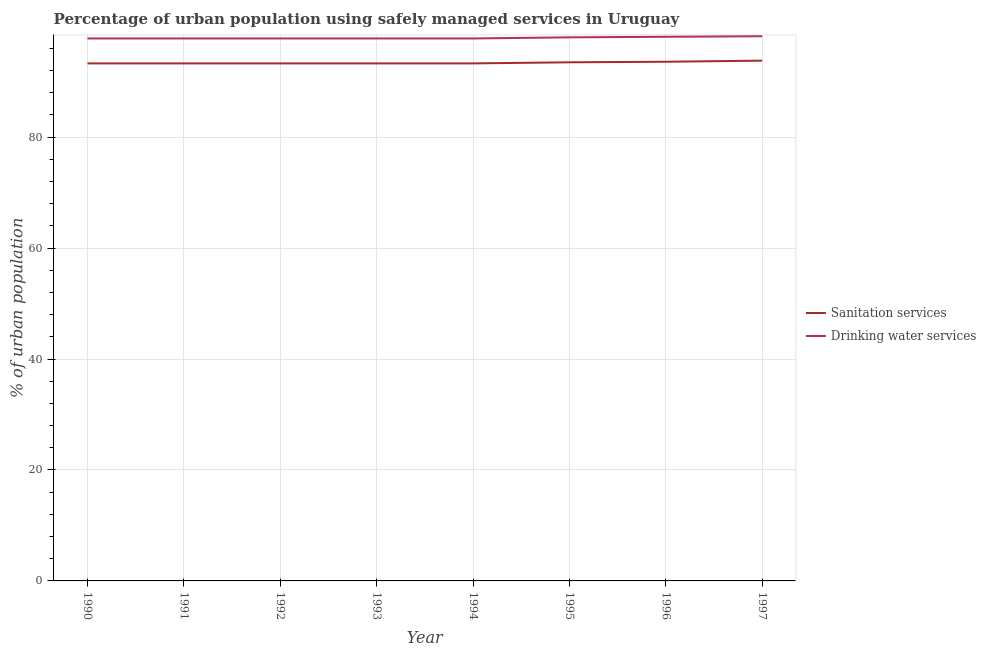How many different coloured lines are there?
Ensure brevity in your answer.  2. What is the percentage of urban population who used drinking water services in 1991?
Ensure brevity in your answer.  97.8. Across all years, what is the maximum percentage of urban population who used sanitation services?
Give a very brief answer. 93.8. Across all years, what is the minimum percentage of urban population who used sanitation services?
Offer a very short reply. 93.3. In which year was the percentage of urban population who used sanitation services maximum?
Make the answer very short. 1997. What is the total percentage of urban population who used sanitation services in the graph?
Provide a succinct answer. 747.4. What is the difference between the percentage of urban population who used sanitation services in 1991 and the percentage of urban population who used drinking water services in 1996?
Your answer should be very brief. -4.8. What is the average percentage of urban population who used sanitation services per year?
Ensure brevity in your answer.  93.42. In the year 1997, what is the difference between the percentage of urban population who used sanitation services and percentage of urban population who used drinking water services?
Your answer should be very brief. -4.4. In how many years, is the percentage of urban population who used drinking water services greater than 48 %?
Your response must be concise. 8. Is the percentage of urban population who used sanitation services in 1993 less than that in 1995?
Make the answer very short. Yes. What is the difference between the highest and the second highest percentage of urban population who used drinking water services?
Provide a short and direct response. 0.1. What is the difference between the highest and the lowest percentage of urban population who used drinking water services?
Offer a very short reply. 0.4. Is the sum of the percentage of urban population who used drinking water services in 1992 and 1993 greater than the maximum percentage of urban population who used sanitation services across all years?
Ensure brevity in your answer.  Yes. Does the percentage of urban population who used sanitation services monotonically increase over the years?
Give a very brief answer. No. How many lines are there?
Make the answer very short. 2. What is the difference between two consecutive major ticks on the Y-axis?
Keep it short and to the point. 20. Does the graph contain any zero values?
Keep it short and to the point. No. Does the graph contain grids?
Your answer should be compact. Yes. Where does the legend appear in the graph?
Offer a terse response. Center right. What is the title of the graph?
Make the answer very short. Percentage of urban population using safely managed services in Uruguay. Does "% of gross capital formation" appear as one of the legend labels in the graph?
Make the answer very short. No. What is the label or title of the Y-axis?
Offer a very short reply. % of urban population. What is the % of urban population of Sanitation services in 1990?
Give a very brief answer. 93.3. What is the % of urban population in Drinking water services in 1990?
Offer a very short reply. 97.8. What is the % of urban population of Sanitation services in 1991?
Offer a very short reply. 93.3. What is the % of urban population in Drinking water services in 1991?
Offer a very short reply. 97.8. What is the % of urban population of Sanitation services in 1992?
Make the answer very short. 93.3. What is the % of urban population of Drinking water services in 1992?
Provide a short and direct response. 97.8. What is the % of urban population of Sanitation services in 1993?
Your answer should be very brief. 93.3. What is the % of urban population in Drinking water services in 1993?
Your answer should be very brief. 97.8. What is the % of urban population in Sanitation services in 1994?
Provide a succinct answer. 93.3. What is the % of urban population of Drinking water services in 1994?
Offer a terse response. 97.8. What is the % of urban population in Sanitation services in 1995?
Offer a terse response. 93.5. What is the % of urban population of Sanitation services in 1996?
Give a very brief answer. 93.6. What is the % of urban population of Drinking water services in 1996?
Make the answer very short. 98.1. What is the % of urban population of Sanitation services in 1997?
Provide a succinct answer. 93.8. What is the % of urban population in Drinking water services in 1997?
Offer a terse response. 98.2. Across all years, what is the maximum % of urban population of Sanitation services?
Your answer should be very brief. 93.8. Across all years, what is the maximum % of urban population in Drinking water services?
Your answer should be compact. 98.2. Across all years, what is the minimum % of urban population in Sanitation services?
Offer a very short reply. 93.3. Across all years, what is the minimum % of urban population of Drinking water services?
Make the answer very short. 97.8. What is the total % of urban population of Sanitation services in the graph?
Provide a short and direct response. 747.4. What is the total % of urban population in Drinking water services in the graph?
Offer a very short reply. 783.3. What is the difference between the % of urban population of Sanitation services in 1990 and that in 1992?
Your answer should be compact. 0. What is the difference between the % of urban population of Drinking water services in 1990 and that in 1992?
Make the answer very short. 0. What is the difference between the % of urban population of Sanitation services in 1990 and that in 1993?
Offer a very short reply. 0. What is the difference between the % of urban population in Drinking water services in 1990 and that in 1993?
Provide a succinct answer. 0. What is the difference between the % of urban population in Sanitation services in 1990 and that in 1994?
Offer a very short reply. 0. What is the difference between the % of urban population in Sanitation services in 1990 and that in 1996?
Make the answer very short. -0.3. What is the difference between the % of urban population in Sanitation services in 1990 and that in 1997?
Your answer should be compact. -0.5. What is the difference between the % of urban population of Drinking water services in 1990 and that in 1997?
Your answer should be very brief. -0.4. What is the difference between the % of urban population in Drinking water services in 1991 and that in 1992?
Provide a succinct answer. 0. What is the difference between the % of urban population of Sanitation services in 1991 and that in 1993?
Provide a succinct answer. 0. What is the difference between the % of urban population of Sanitation services in 1991 and that in 1997?
Your answer should be compact. -0.5. What is the difference between the % of urban population of Drinking water services in 1991 and that in 1997?
Give a very brief answer. -0.4. What is the difference between the % of urban population of Drinking water services in 1992 and that in 1993?
Your answer should be very brief. 0. What is the difference between the % of urban population in Sanitation services in 1992 and that in 1994?
Offer a terse response. 0. What is the difference between the % of urban population of Sanitation services in 1992 and that in 1995?
Make the answer very short. -0.2. What is the difference between the % of urban population of Drinking water services in 1992 and that in 1997?
Give a very brief answer. -0.4. What is the difference between the % of urban population in Sanitation services in 1993 and that in 1995?
Make the answer very short. -0.2. What is the difference between the % of urban population in Drinking water services in 1993 and that in 1995?
Your response must be concise. -0.2. What is the difference between the % of urban population of Sanitation services in 1993 and that in 1996?
Provide a succinct answer. -0.3. What is the difference between the % of urban population in Drinking water services in 1993 and that in 1997?
Make the answer very short. -0.4. What is the difference between the % of urban population of Sanitation services in 1994 and that in 1995?
Ensure brevity in your answer.  -0.2. What is the difference between the % of urban population in Sanitation services in 1994 and that in 1996?
Provide a succinct answer. -0.3. What is the difference between the % of urban population of Sanitation services in 1995 and that in 1996?
Ensure brevity in your answer.  -0.1. What is the difference between the % of urban population of Sanitation services in 1995 and that in 1997?
Ensure brevity in your answer.  -0.3. What is the difference between the % of urban population in Drinking water services in 1995 and that in 1997?
Offer a terse response. -0.2. What is the difference between the % of urban population in Sanitation services in 1990 and the % of urban population in Drinking water services in 1992?
Ensure brevity in your answer.  -4.5. What is the difference between the % of urban population of Sanitation services in 1990 and the % of urban population of Drinking water services in 1993?
Provide a succinct answer. -4.5. What is the difference between the % of urban population in Sanitation services in 1990 and the % of urban population in Drinking water services in 1994?
Offer a very short reply. -4.5. What is the difference between the % of urban population in Sanitation services in 1990 and the % of urban population in Drinking water services in 1996?
Give a very brief answer. -4.8. What is the difference between the % of urban population of Sanitation services in 1991 and the % of urban population of Drinking water services in 1993?
Your answer should be compact. -4.5. What is the difference between the % of urban population in Sanitation services in 1991 and the % of urban population in Drinking water services in 1996?
Your answer should be very brief. -4.8. What is the difference between the % of urban population of Sanitation services in 1991 and the % of urban population of Drinking water services in 1997?
Keep it short and to the point. -4.9. What is the difference between the % of urban population of Sanitation services in 1992 and the % of urban population of Drinking water services in 1993?
Ensure brevity in your answer.  -4.5. What is the difference between the % of urban population in Sanitation services in 1992 and the % of urban population in Drinking water services in 1995?
Provide a short and direct response. -4.7. What is the difference between the % of urban population in Sanitation services in 1993 and the % of urban population in Drinking water services in 1997?
Offer a terse response. -4.9. What is the difference between the % of urban population of Sanitation services in 1994 and the % of urban population of Drinking water services in 1995?
Offer a terse response. -4.7. What is the difference between the % of urban population in Sanitation services in 1994 and the % of urban population in Drinking water services in 1996?
Your response must be concise. -4.8. What is the difference between the % of urban population of Sanitation services in 1994 and the % of urban population of Drinking water services in 1997?
Your answer should be very brief. -4.9. What is the difference between the % of urban population in Sanitation services in 1995 and the % of urban population in Drinking water services in 1997?
Offer a terse response. -4.7. What is the difference between the % of urban population in Sanitation services in 1996 and the % of urban population in Drinking water services in 1997?
Give a very brief answer. -4.6. What is the average % of urban population in Sanitation services per year?
Your answer should be compact. 93.42. What is the average % of urban population of Drinking water services per year?
Keep it short and to the point. 97.91. In the year 1990, what is the difference between the % of urban population of Sanitation services and % of urban population of Drinking water services?
Give a very brief answer. -4.5. In the year 1994, what is the difference between the % of urban population in Sanitation services and % of urban population in Drinking water services?
Your response must be concise. -4.5. In the year 1996, what is the difference between the % of urban population in Sanitation services and % of urban population in Drinking water services?
Offer a very short reply. -4.5. In the year 1997, what is the difference between the % of urban population in Sanitation services and % of urban population in Drinking water services?
Keep it short and to the point. -4.4. What is the ratio of the % of urban population of Sanitation services in 1990 to that in 1991?
Your answer should be very brief. 1. What is the ratio of the % of urban population in Sanitation services in 1990 to that in 1992?
Offer a terse response. 1. What is the ratio of the % of urban population in Drinking water services in 1990 to that in 1992?
Keep it short and to the point. 1. What is the ratio of the % of urban population in Drinking water services in 1990 to that in 1993?
Your answer should be very brief. 1. What is the ratio of the % of urban population in Sanitation services in 1990 to that in 1994?
Provide a succinct answer. 1. What is the ratio of the % of urban population of Drinking water services in 1990 to that in 1994?
Your answer should be compact. 1. What is the ratio of the % of urban population in Sanitation services in 1990 to that in 1995?
Your response must be concise. 1. What is the ratio of the % of urban population of Drinking water services in 1990 to that in 1995?
Give a very brief answer. 1. What is the ratio of the % of urban population in Sanitation services in 1990 to that in 1996?
Your answer should be compact. 1. What is the ratio of the % of urban population in Drinking water services in 1990 to that in 1996?
Provide a short and direct response. 1. What is the ratio of the % of urban population of Drinking water services in 1991 to that in 1992?
Provide a succinct answer. 1. What is the ratio of the % of urban population in Sanitation services in 1991 to that in 1996?
Give a very brief answer. 1. What is the ratio of the % of urban population of Drinking water services in 1992 to that in 1993?
Your response must be concise. 1. What is the ratio of the % of urban population of Drinking water services in 1992 to that in 1995?
Your answer should be very brief. 1. What is the ratio of the % of urban population in Drinking water services in 1992 to that in 1996?
Give a very brief answer. 1. What is the ratio of the % of urban population of Drinking water services in 1992 to that in 1997?
Offer a very short reply. 1. What is the ratio of the % of urban population of Sanitation services in 1993 to that in 1994?
Ensure brevity in your answer.  1. What is the ratio of the % of urban population of Drinking water services in 1993 to that in 1994?
Offer a terse response. 1. What is the ratio of the % of urban population of Drinking water services in 1993 to that in 1996?
Offer a very short reply. 1. What is the ratio of the % of urban population in Sanitation services in 1993 to that in 1997?
Make the answer very short. 0.99. What is the ratio of the % of urban population in Sanitation services in 1994 to that in 1996?
Provide a succinct answer. 1. What is the ratio of the % of urban population of Sanitation services in 1994 to that in 1997?
Your response must be concise. 0.99. What is the ratio of the % of urban population in Drinking water services in 1995 to that in 1996?
Offer a terse response. 1. What is the ratio of the % of urban population in Sanitation services in 1995 to that in 1997?
Make the answer very short. 1. What is the ratio of the % of urban population in Drinking water services in 1995 to that in 1997?
Provide a succinct answer. 1. What is the ratio of the % of urban population of Sanitation services in 1996 to that in 1997?
Keep it short and to the point. 1. What is the difference between the highest and the second highest % of urban population of Drinking water services?
Your answer should be compact. 0.1. What is the difference between the highest and the lowest % of urban population of Sanitation services?
Give a very brief answer. 0.5. What is the difference between the highest and the lowest % of urban population of Drinking water services?
Make the answer very short. 0.4. 